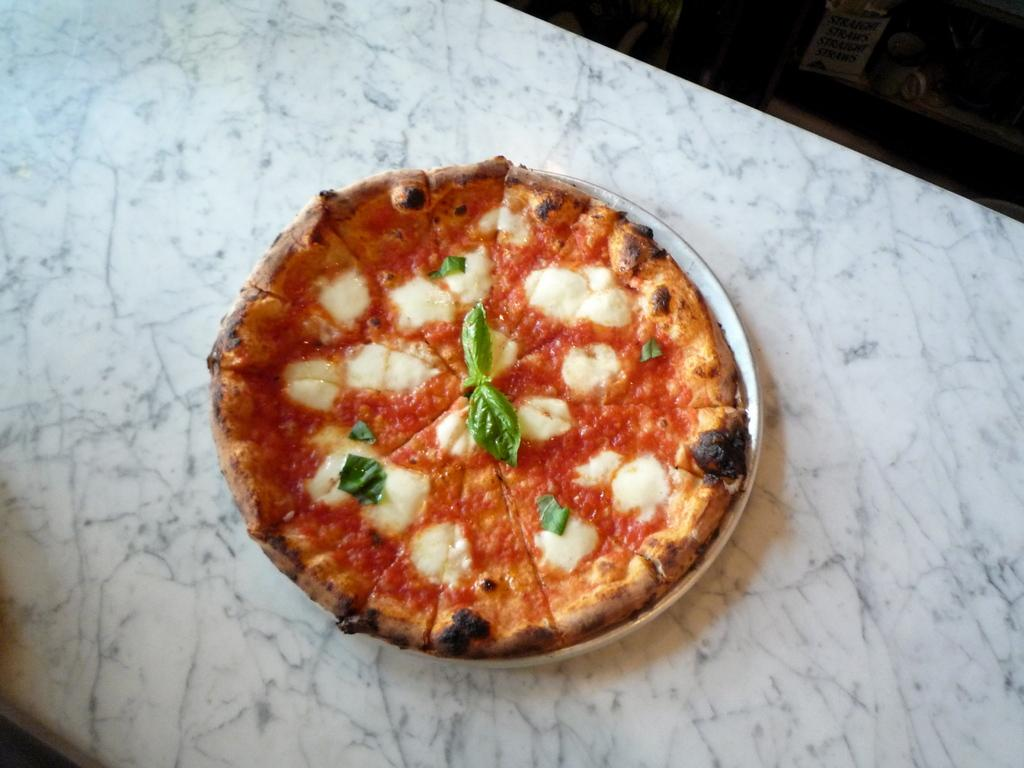What is present on the table in the image? There is food on the table in the image. What type of fan is visible in the image? A: There is no fan present in the image. Can you turn the food into a different dish in the image? The food cannot be turned into a different dish in the image, as it is a static representation. 